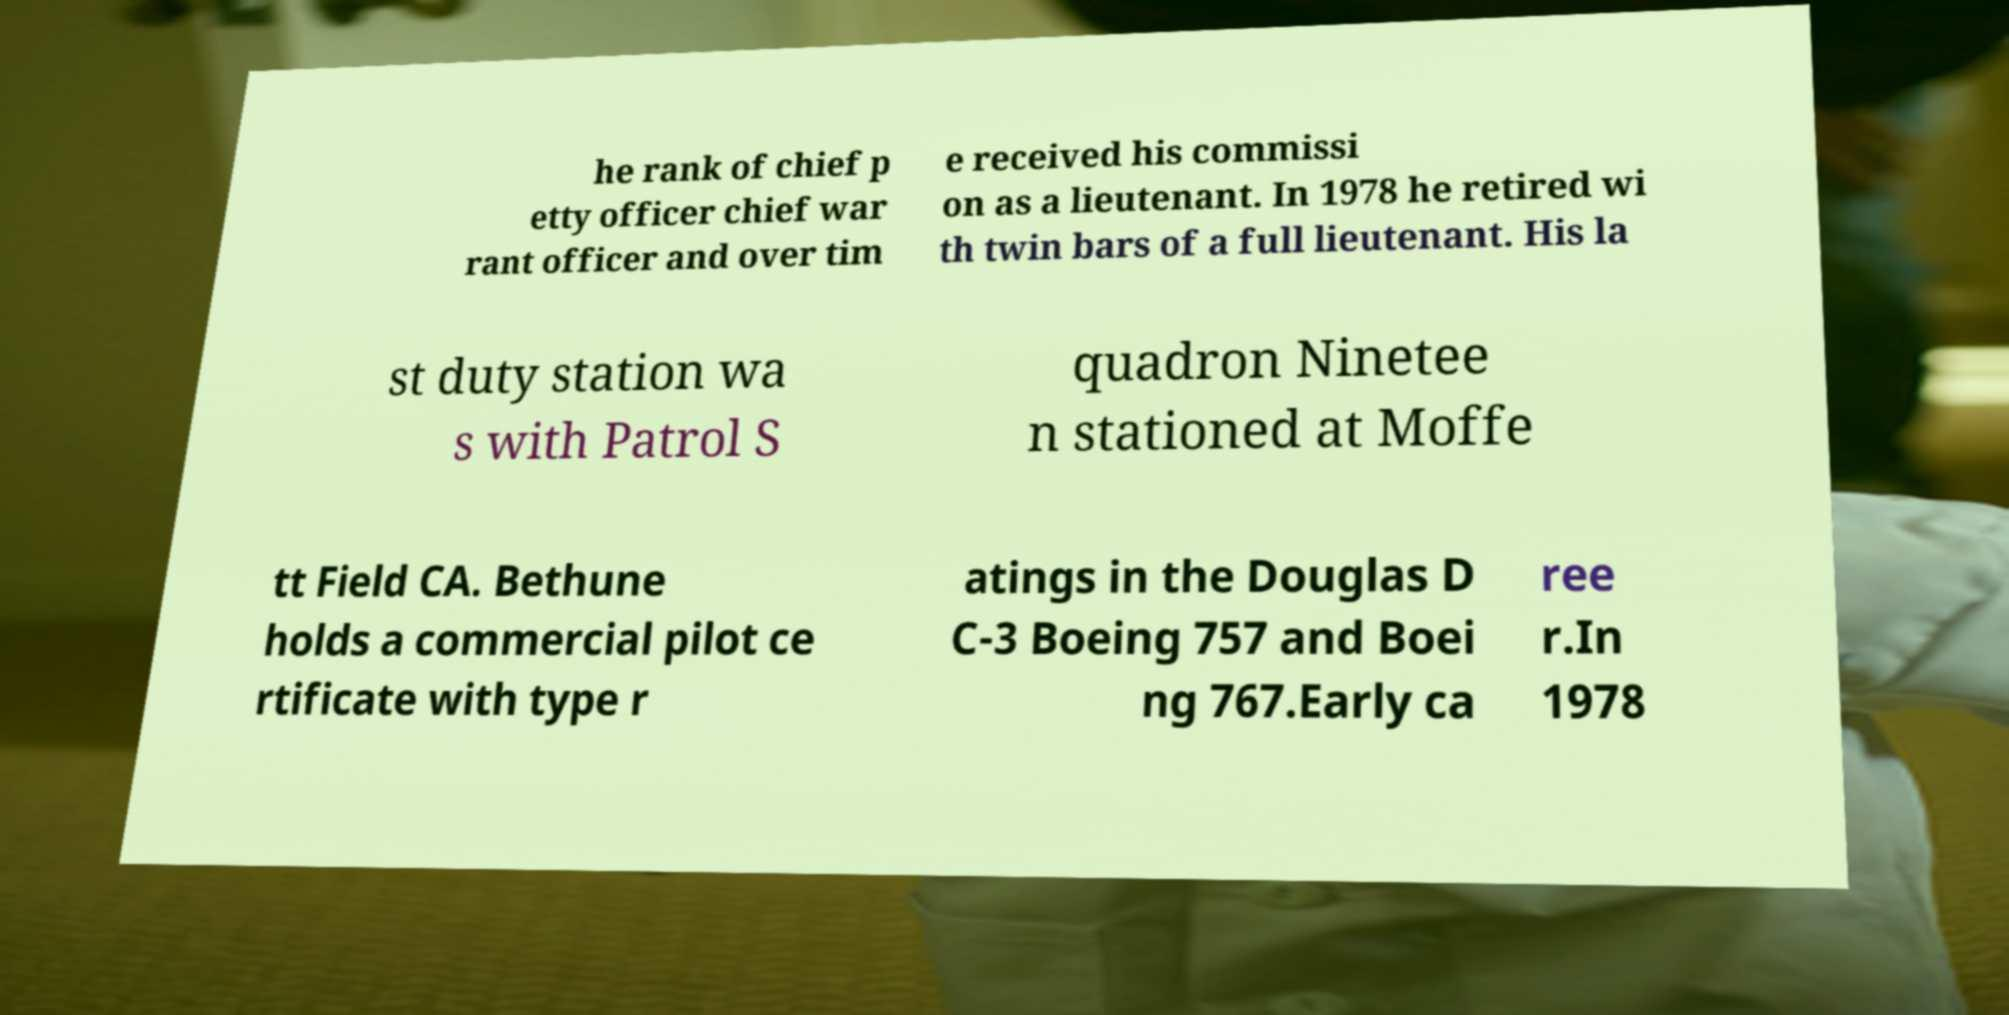What messages or text are displayed in this image? I need them in a readable, typed format. he rank of chief p etty officer chief war rant officer and over tim e received his commissi on as a lieutenant. In 1978 he retired wi th twin bars of a full lieutenant. His la st duty station wa s with Patrol S quadron Ninetee n stationed at Moffe tt Field CA. Bethune holds a commercial pilot ce rtificate with type r atings in the Douglas D C-3 Boeing 757 and Boei ng 767.Early ca ree r.In 1978 